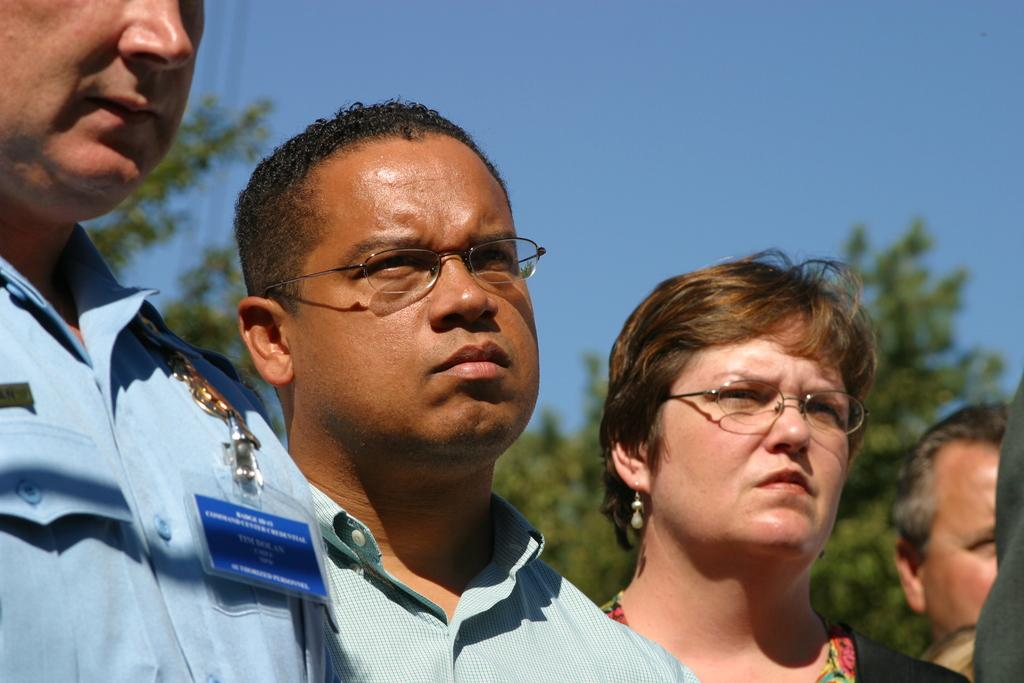What can be seen in the foreground of the picture? There are people standing in the foreground of the picture. How would you describe the background of the image? The background of the image is blurred. What type of natural elements are visible in the background? There are trees in the background of the image. Are there any man-made structures or objects in the background? Yes, cables are present in the background of the image. What is the weather like in the image? The sky is clear and it is sunny in the image. What type of learning test is being conducted in the image? There is no learning test or any indication of a test being conducted in the image. Can you see a rod being used by the people in the image? There is no rod visible in the image. 